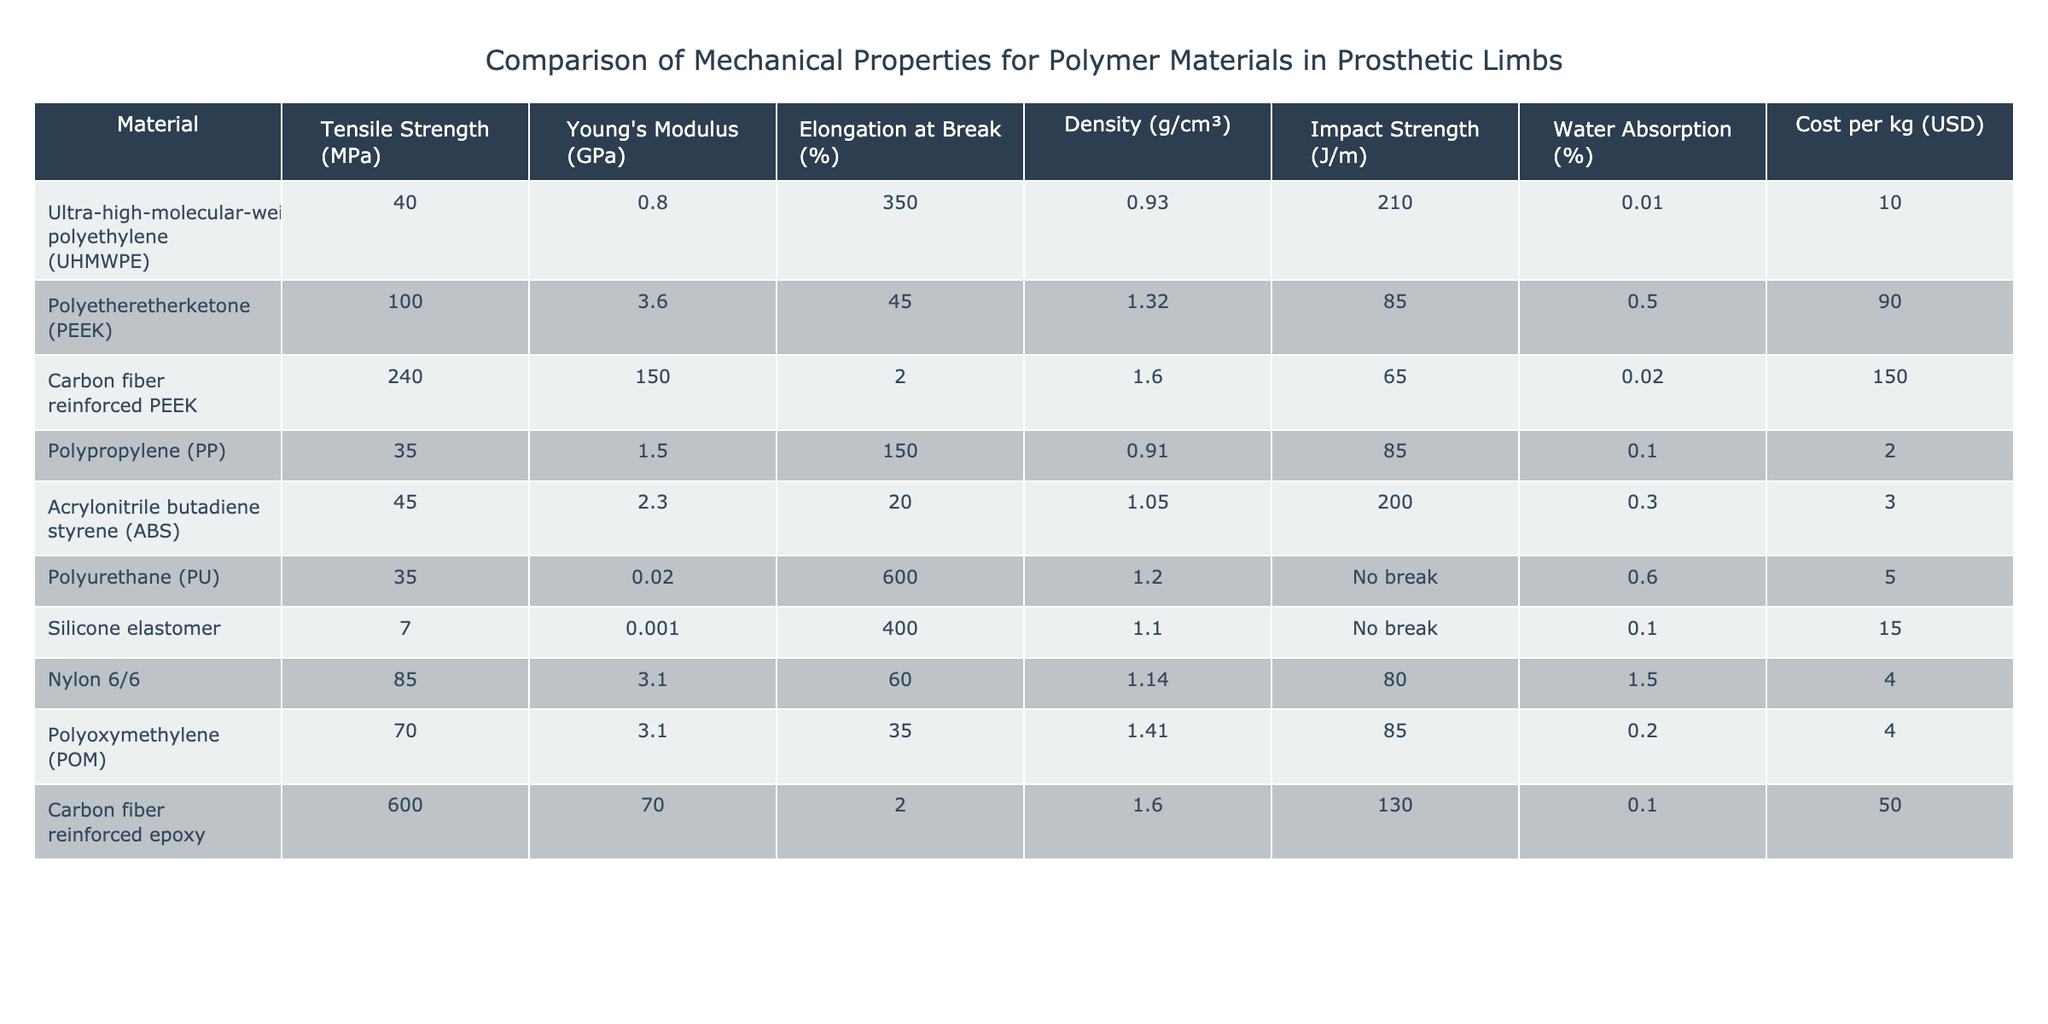What is the tensile strength of Carbon fiber reinforced epoxy? The table lists the tensile strength of Carbon fiber reinforced epoxy as 600 MPa, which is the value corresponding to that specific material in the 'Tensile Strength (MPa)' column.
Answer: 600 MPa Which polymer material has the highest Young's Modulus? By reviewing the values in the 'Young's Modulus (GPa)' column, Carbon fiber reinforced PEEK has the highest value at 150 GPa, confirming it is the material with the greatest stiffness.
Answer: 150 GPa How does the impact strength of Ultra-high-molecular-weight polyethylene compare to that of Polypropylene? The impact strength of Ultra-high-molecular-weight polyethylene is 210 J/m, whereas Polypropylene has an impact strength of 85 J/m. Thus, UHMWPE is stronger due to its higher value.
Answer: UHMWPE is stronger What is the average elongation at break of all the polymer materials listed? To calculate the average elongation at break, sum the values of all elongation at break percentages (350 + 45 + 2 + 150 + 20 + 600 + 400 + 60 + 35 + 2) = 1664, then divide by the number of materials (10). This gives an average of 1664 / 10 = 166.4%.
Answer: 166.4% Does Polyurethane have a higher density than Nylon 6/6? The density of Polyurethane is 1.2 g/cm³ and for Nylon 6/6, it is 1.14 g/cm³. Since 1.2 is greater than 1.14, Polyurethane has a higher density than Nylon 6/6.
Answer: Yes Which material has the lowest cost per kg, and what is its value? The table shows that Polypropylene (PP) has the lowest cost per kg at 2 USD, as this is the minimum value in the 'Cost per kg (USD)' column.
Answer: 2 USD What polymer material has both high tensile strength and high elongation at break? To find a material with high tensile strength and elongation, look for entries with both values above their averages: Carbon fiber reinforced PEEK (240 MPa and 2%) does not satisfy this, while Polyurethane has a high elongation at 600% but lower tensile strength (35 MPa); thus none of them meet the criteria simultaneously.
Answer: None Is the water absorption of Silicone elastomer less than 0.1%? The water absorption of Silicone elastomer is 0.1%, which is equal to 0.1%. Therefore, it is not less.
Answer: No Which two materials have impact strength values greater than 100 J/m? Upon examining the 'Impact Strength (J/m)' column, the materials with values greater than 100 J/m are Ultra-high-molecular-weight polyethylene (210 J/m) and Carbon fiber reinforced epoxy (130 J/m), which confirms the requirement.
Answer: UHMWPE and Carbon fiber reinforced epoxy 